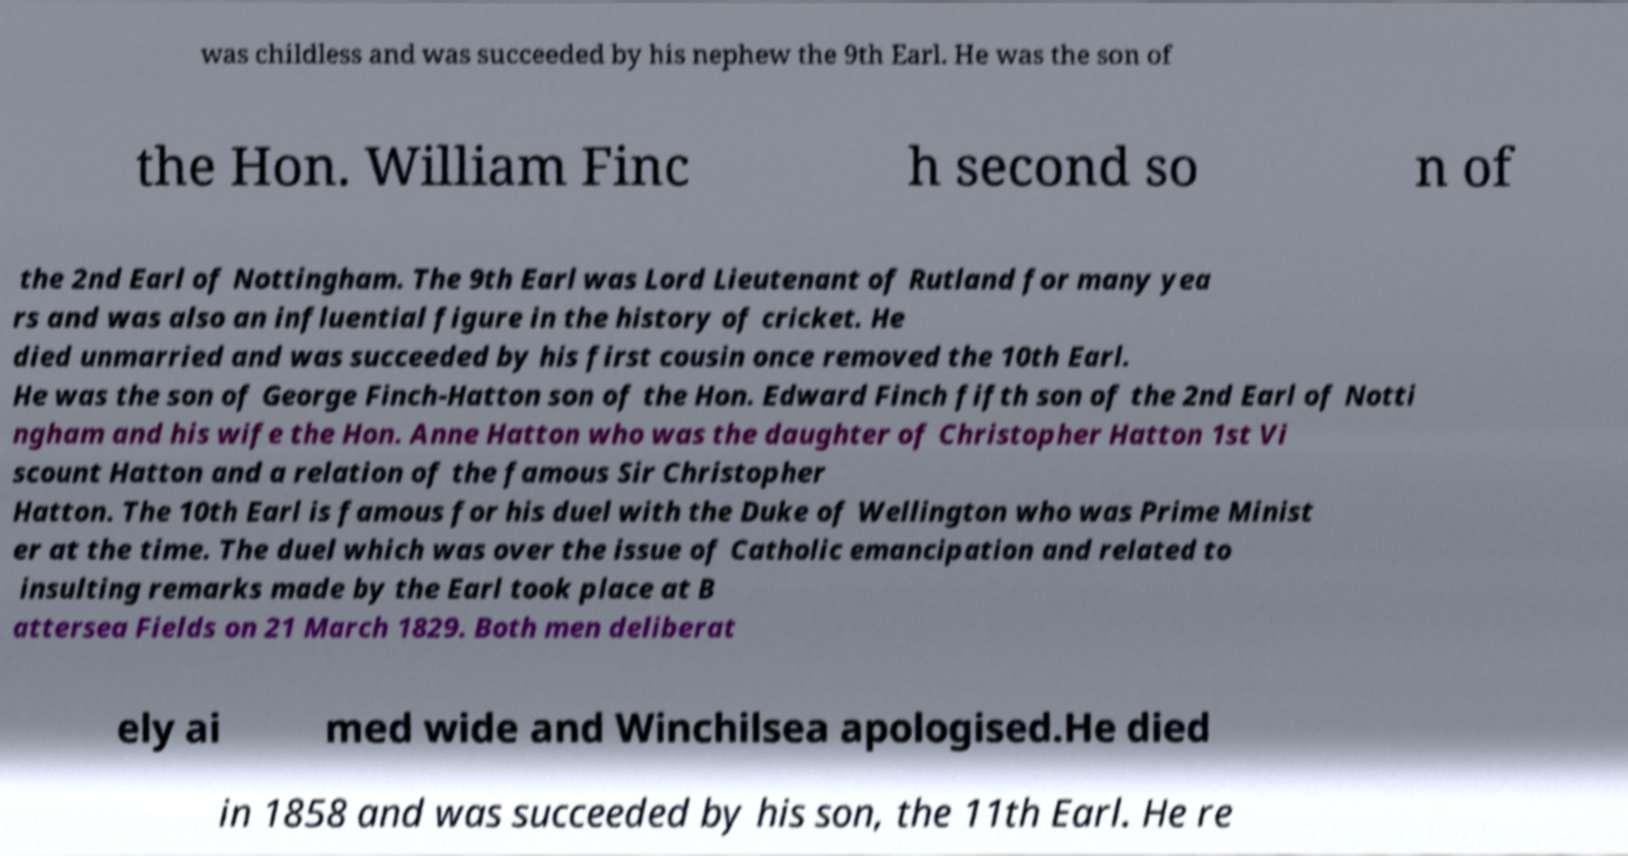There's text embedded in this image that I need extracted. Can you transcribe it verbatim? was childless and was succeeded by his nephew the 9th Earl. He was the son of the Hon. William Finc h second so n of the 2nd Earl of Nottingham. The 9th Earl was Lord Lieutenant of Rutland for many yea rs and was also an influential figure in the history of cricket. He died unmarried and was succeeded by his first cousin once removed the 10th Earl. He was the son of George Finch-Hatton son of the Hon. Edward Finch fifth son of the 2nd Earl of Notti ngham and his wife the Hon. Anne Hatton who was the daughter of Christopher Hatton 1st Vi scount Hatton and a relation of the famous Sir Christopher Hatton. The 10th Earl is famous for his duel with the Duke of Wellington who was Prime Minist er at the time. The duel which was over the issue of Catholic emancipation and related to insulting remarks made by the Earl took place at B attersea Fields on 21 March 1829. Both men deliberat ely ai med wide and Winchilsea apologised.He died in 1858 and was succeeded by his son, the 11th Earl. He re 